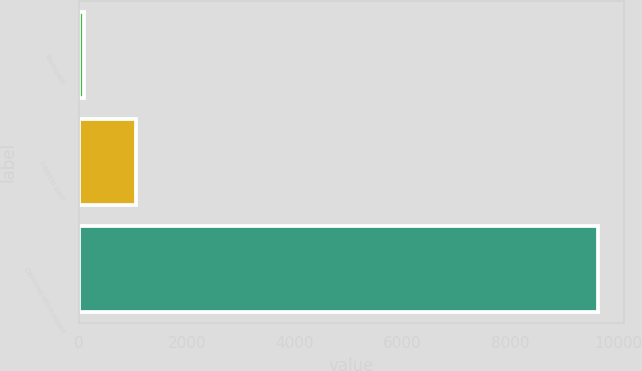Convert chart. <chart><loc_0><loc_0><loc_500><loc_500><bar_chart><fcel>Taxespaid<fcel>Interest paid<fcel>Deferred stock-based<nl><fcel>100<fcel>1052.7<fcel>9627<nl></chart> 